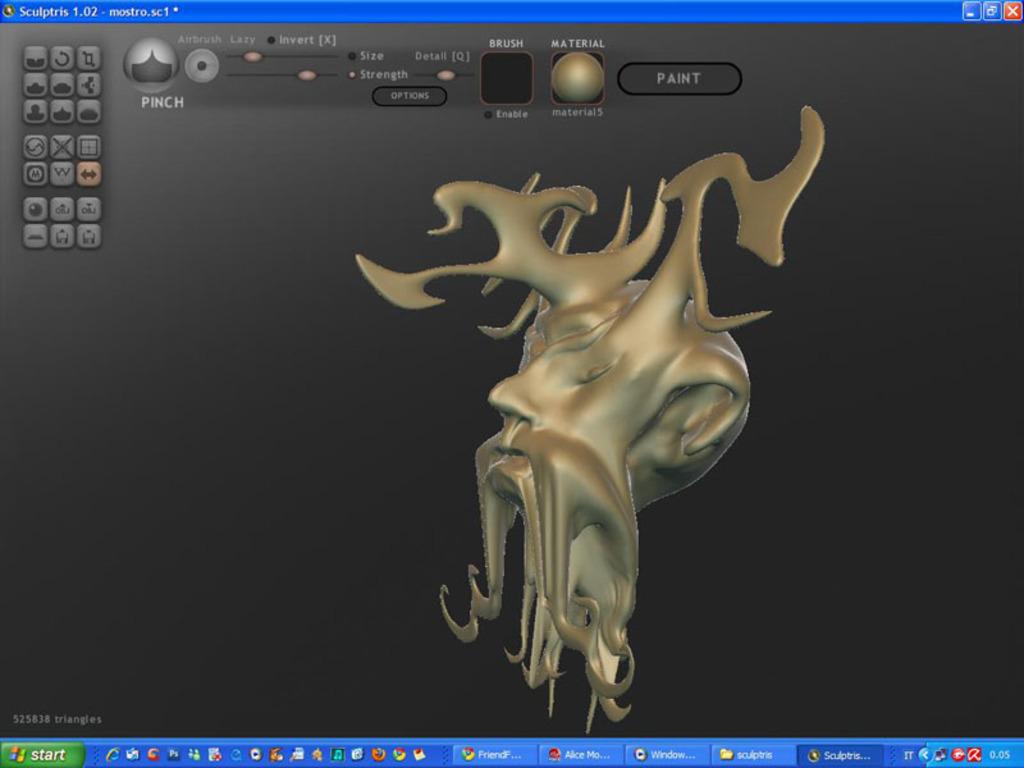What is the name of the program being used?
Give a very brief answer. Sculptris. 